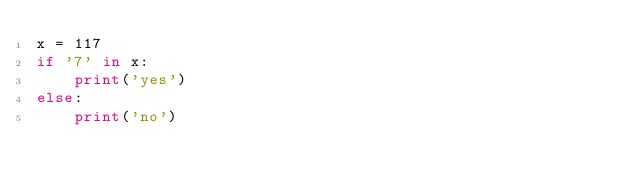<code> <loc_0><loc_0><loc_500><loc_500><_Python_>x = 117
if '7' in x:
    print('yes')
else:
    print('no')</code> 